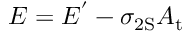Convert formula to latex. <formula><loc_0><loc_0><loc_500><loc_500>E = E ^ { ^ { \prime } } - \sigma _ { 2 S } A _ { t }</formula> 